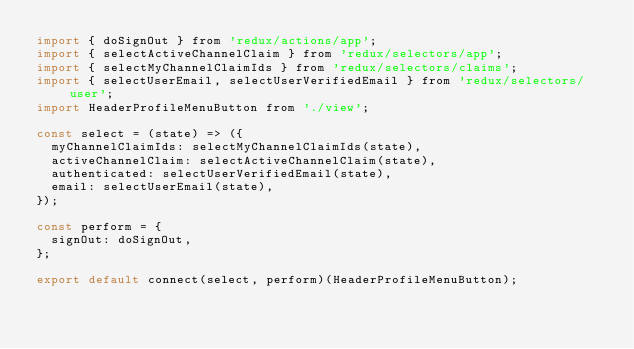<code> <loc_0><loc_0><loc_500><loc_500><_JavaScript_>import { doSignOut } from 'redux/actions/app';
import { selectActiveChannelClaim } from 'redux/selectors/app';
import { selectMyChannelClaimIds } from 'redux/selectors/claims';
import { selectUserEmail, selectUserVerifiedEmail } from 'redux/selectors/user';
import HeaderProfileMenuButton from './view';

const select = (state) => ({
  myChannelClaimIds: selectMyChannelClaimIds(state),
  activeChannelClaim: selectActiveChannelClaim(state),
  authenticated: selectUserVerifiedEmail(state),
  email: selectUserEmail(state),
});

const perform = {
  signOut: doSignOut,
};

export default connect(select, perform)(HeaderProfileMenuButton);
</code> 